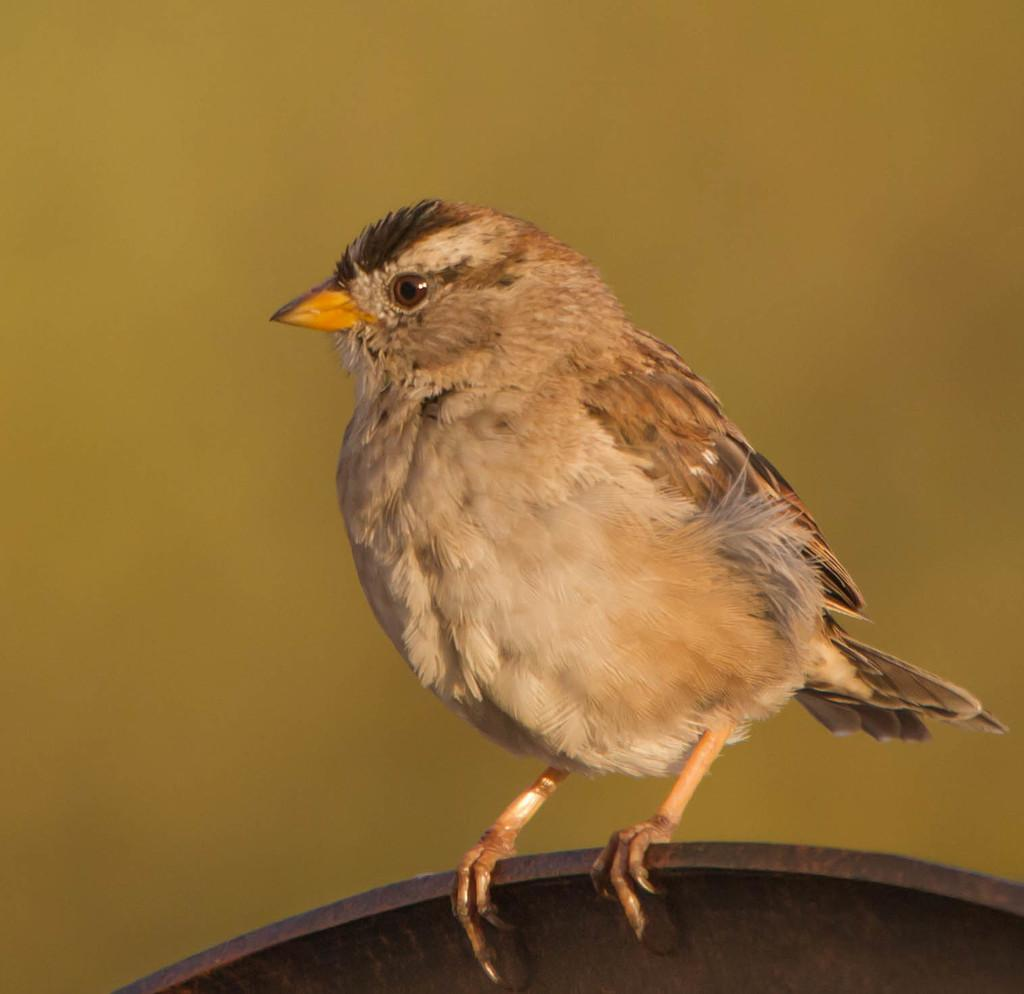What type of animal can be seen in the image? There is a bird in the image. Where is the bird located in the image? The bird is on the surface of something, possibly water or ground. What is the color of the background in the image? The background of the image is in a dark color. Reasoning: Let' Let's think step by step in order to produce the conversation. We start by identifying the main subject in the image, which is the bird. Then, we describe the bird's location, noting that it is on the surface of something. Finally, we mention the background color, which is dark. We avoid making assumptions about the surface the bird is on and focus on the facts provided. Absurd Question/Answer: How many homes can be seen in the image? There is no mention of a home in the image, so we cannot determine the number of homes present. Is the bird taking a bath in a tub in the image? There is no tub present in the image, so we cannot determine if the bird is taking a bath. 